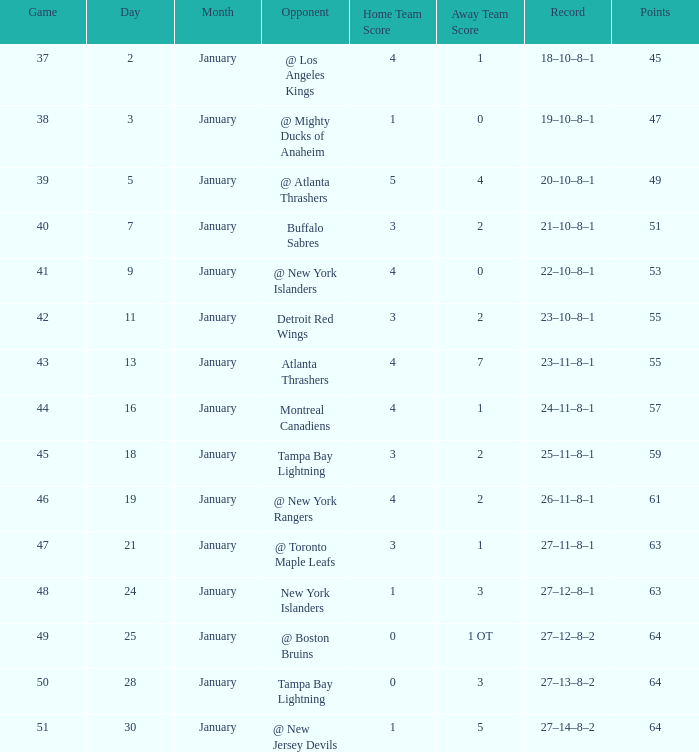Which points feature a score of 4-1, an 18-10-8-1 record, and a january that is more than 2? None. 